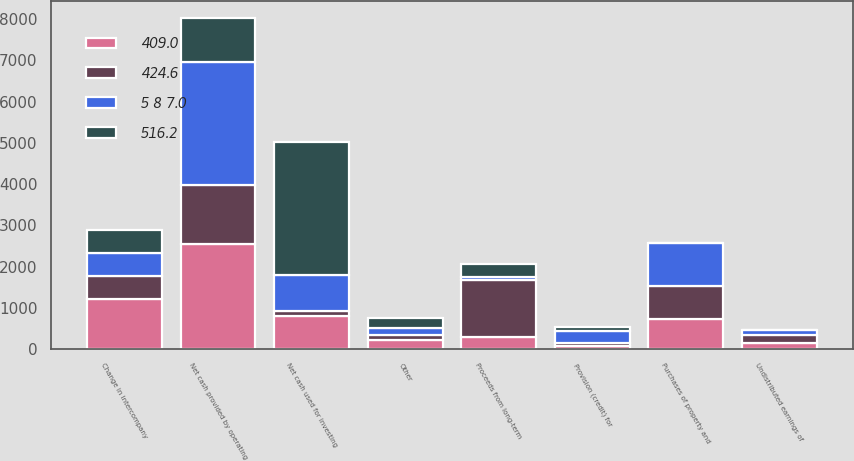<chart> <loc_0><loc_0><loc_500><loc_500><stacked_bar_chart><ecel><fcel>Undistributed earnings of<fcel>Provision (credit) for<fcel>Other<fcel>Net cash provided by operating<fcel>Purchases of property and<fcel>Net cash used for investing<fcel>Change in intercompany<fcel>Proceeds from long-term<nl><fcel>5 8 7.0<fcel>118.8<fcel>278.3<fcel>168<fcel>2998.4<fcel>1054.3<fcel>855.3<fcel>552.6<fcel>69<nl><fcel>409.0<fcel>156.7<fcel>74.8<fcel>221.6<fcel>2544.9<fcel>735.5<fcel>814.5<fcel>1229.9<fcel>305<nl><fcel>424.6<fcel>195.1<fcel>83.2<fcel>123.7<fcel>1424.6<fcel>788<fcel>122.7<fcel>550.9<fcel>1384.8<nl><fcel>516.2<fcel>1<fcel>110.2<fcel>245<fcel>1065<fcel>2.4<fcel>3231.4<fcel>552.6<fcel>305<nl></chart> 